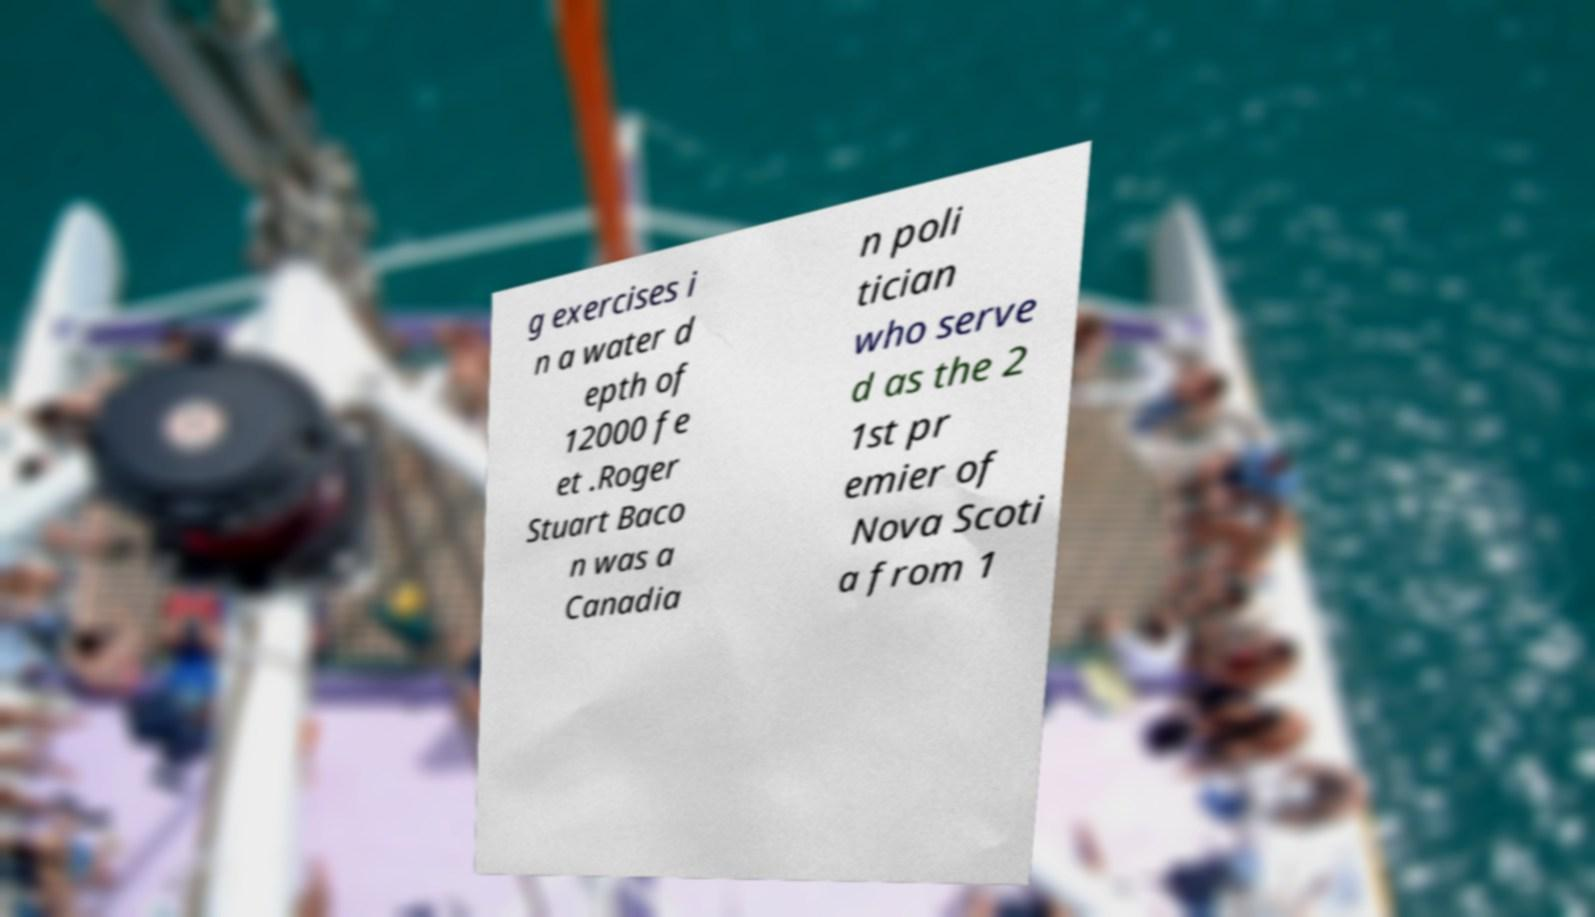Please identify and transcribe the text found in this image. g exercises i n a water d epth of 12000 fe et .Roger Stuart Baco n was a Canadia n poli tician who serve d as the 2 1st pr emier of Nova Scoti a from 1 